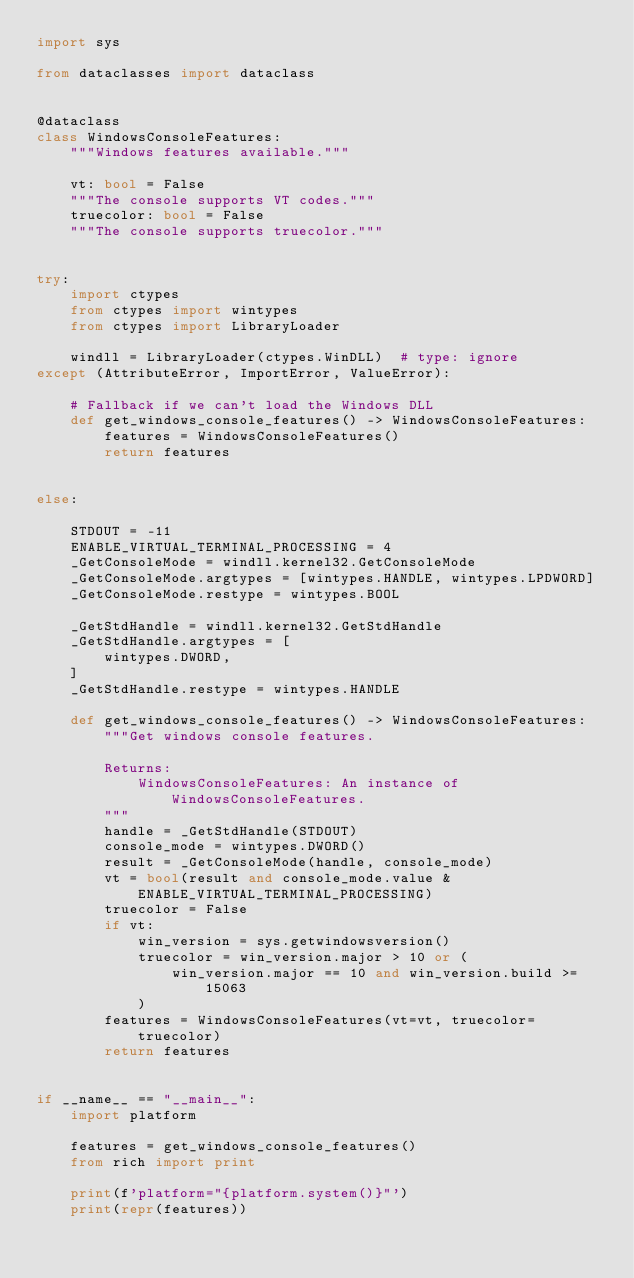Convert code to text. <code><loc_0><loc_0><loc_500><loc_500><_Python_>import sys

from dataclasses import dataclass


@dataclass
class WindowsConsoleFeatures:
    """Windows features available."""

    vt: bool = False
    """The console supports VT codes."""
    truecolor: bool = False
    """The console supports truecolor."""


try:
    import ctypes
    from ctypes import wintypes
    from ctypes import LibraryLoader

    windll = LibraryLoader(ctypes.WinDLL)  # type: ignore
except (AttributeError, ImportError, ValueError):

    # Fallback if we can't load the Windows DLL
    def get_windows_console_features() -> WindowsConsoleFeatures:
        features = WindowsConsoleFeatures()
        return features


else:

    STDOUT = -11
    ENABLE_VIRTUAL_TERMINAL_PROCESSING = 4
    _GetConsoleMode = windll.kernel32.GetConsoleMode
    _GetConsoleMode.argtypes = [wintypes.HANDLE, wintypes.LPDWORD]
    _GetConsoleMode.restype = wintypes.BOOL

    _GetStdHandle = windll.kernel32.GetStdHandle
    _GetStdHandle.argtypes = [
        wintypes.DWORD,
    ]
    _GetStdHandle.restype = wintypes.HANDLE

    def get_windows_console_features() -> WindowsConsoleFeatures:
        """Get windows console features.

        Returns:
            WindowsConsoleFeatures: An instance of WindowsConsoleFeatures.
        """
        handle = _GetStdHandle(STDOUT)
        console_mode = wintypes.DWORD()
        result = _GetConsoleMode(handle, console_mode)
        vt = bool(result and console_mode.value & ENABLE_VIRTUAL_TERMINAL_PROCESSING)
        truecolor = False
        if vt:
            win_version = sys.getwindowsversion()
            truecolor = win_version.major > 10 or (
                win_version.major == 10 and win_version.build >= 15063
            )
        features = WindowsConsoleFeatures(vt=vt, truecolor=truecolor)
        return features


if __name__ == "__main__":
    import platform

    features = get_windows_console_features()
    from rich import print

    print(f'platform="{platform.system()}"')
    print(repr(features))

</code> 